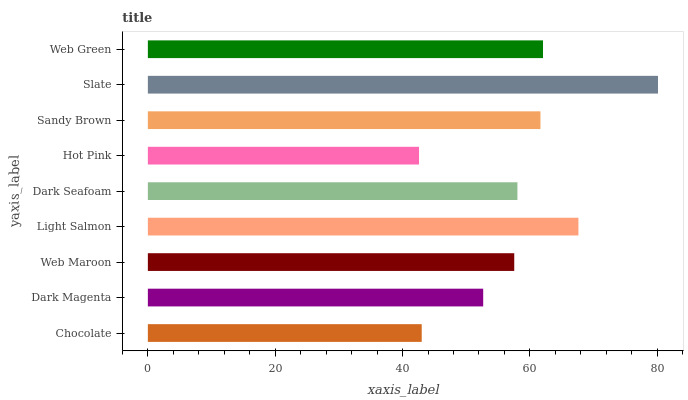Is Hot Pink the minimum?
Answer yes or no. Yes. Is Slate the maximum?
Answer yes or no. Yes. Is Dark Magenta the minimum?
Answer yes or no. No. Is Dark Magenta the maximum?
Answer yes or no. No. Is Dark Magenta greater than Chocolate?
Answer yes or no. Yes. Is Chocolate less than Dark Magenta?
Answer yes or no. Yes. Is Chocolate greater than Dark Magenta?
Answer yes or no. No. Is Dark Magenta less than Chocolate?
Answer yes or no. No. Is Dark Seafoam the high median?
Answer yes or no. Yes. Is Dark Seafoam the low median?
Answer yes or no. Yes. Is Hot Pink the high median?
Answer yes or no. No. Is Slate the low median?
Answer yes or no. No. 